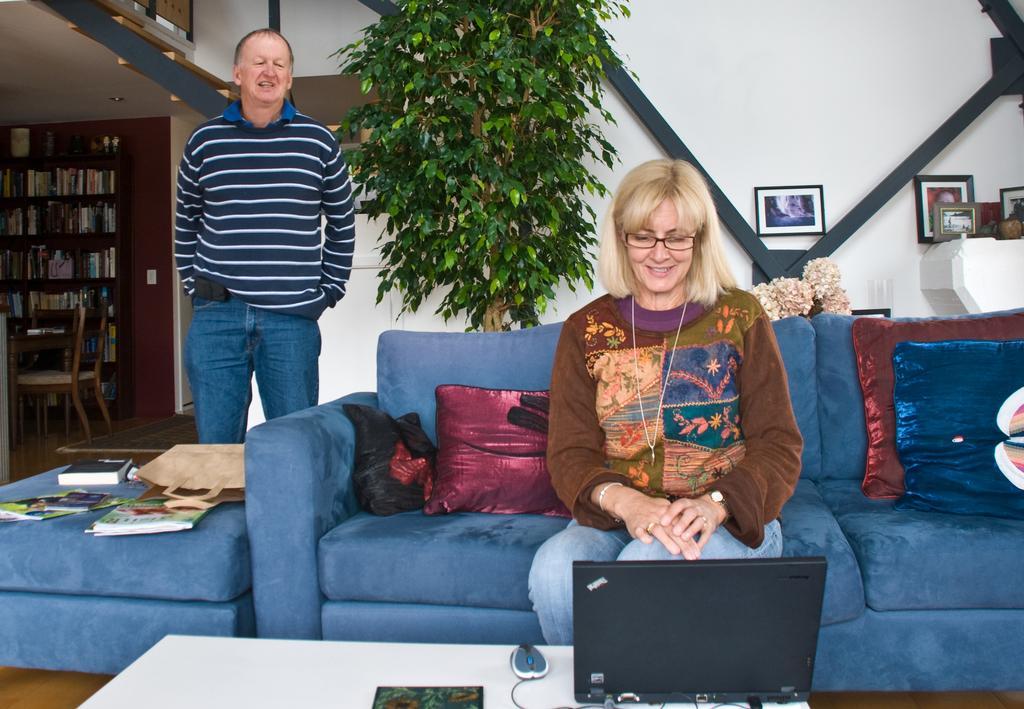In one or two sentences, can you explain what this image depicts? This woman is sitting on a blue couch with pillows. On this table there is a mouse and laptop. On this couch there are books and bag. This rack is filled with books. These are chairs. This person is standing. Picture is on wall. This is tree. 